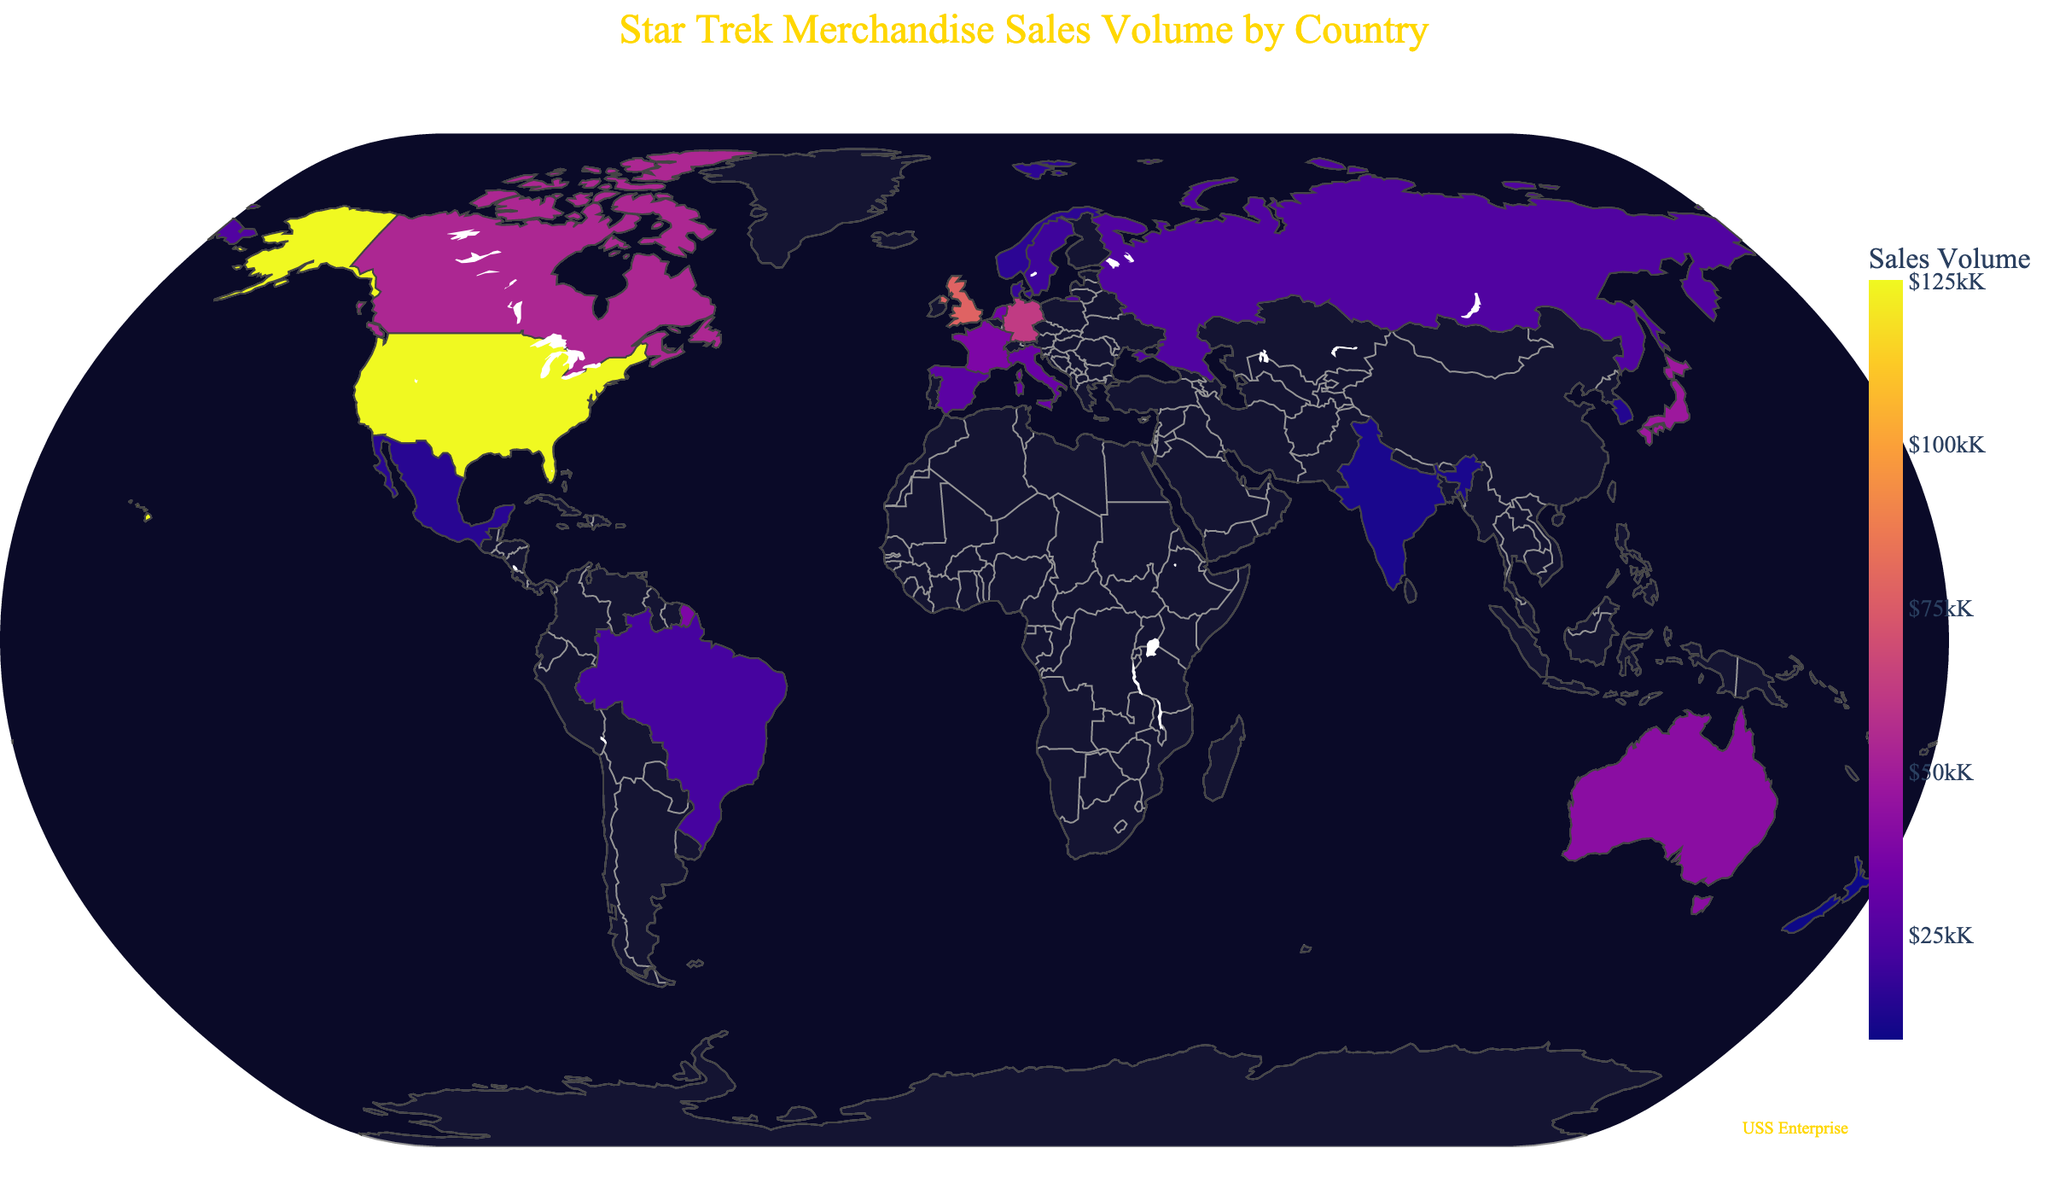How many countries are shown in the sales data? Count the number of data points on the map representing different countries.
Answer: 20 Which country has the highest sales volume? Identify the country with the darkest color representing the highest sales volume.
Answer: United States Between the United Kingdom and Germany, which country has higher sales volume? Compare the color intensities of the United Kingdom and Germany to determine which is darker (has higher sales).
Answer: United Kingdom What's the total sales volume for the United States and Canada combined? Add the sales volumes of the United States (125,000) and Canada (54,000).
Answer: 179,000 Which country has the lowest sales volume? Identify the country with the lightest color representing the lowest sales volume.
Answer: New Zealand What's the average sales volume among all countries? Sum all sales volumes and divide by the total number of countries (20).
Answer: 30,150 Is Japan's sales volume greater than Australia's sales volume? Compare Japan's sales volume (48,000) with Australia's (42,000).
Answer: Yes How many countries have sales volumes greater than 50,000? Count the number of countries whose sales volumes exceed 50,000 by looking at their color intensity.
Answer: 3 Is the Enterprise starship annotation placed in the ocean or on land? Check the location of the "USS Enterprise" text annotation on the map.
Answer: Ocean What's the difference in sales volume between Germany and France? Subtract France's sales volume (38,000) from Germany's (62,000).
Answer: 24,000 